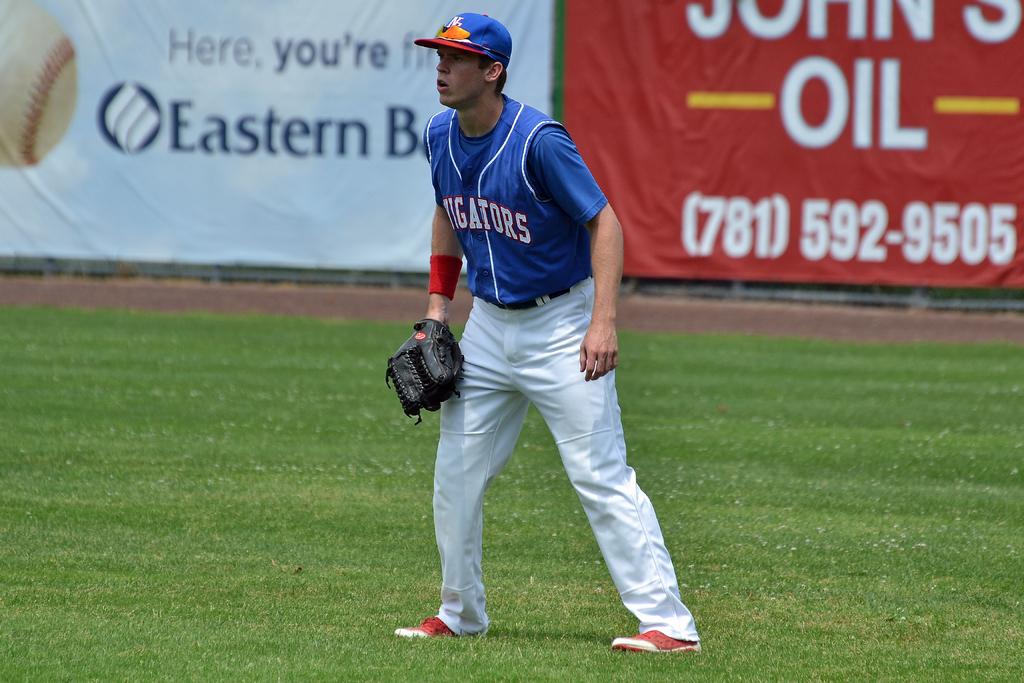What is the phone number on the wall of the stands here?
Provide a short and direct response. (781) 592-9505. What direction is on the sign to the left?
Offer a terse response. Eastern. 